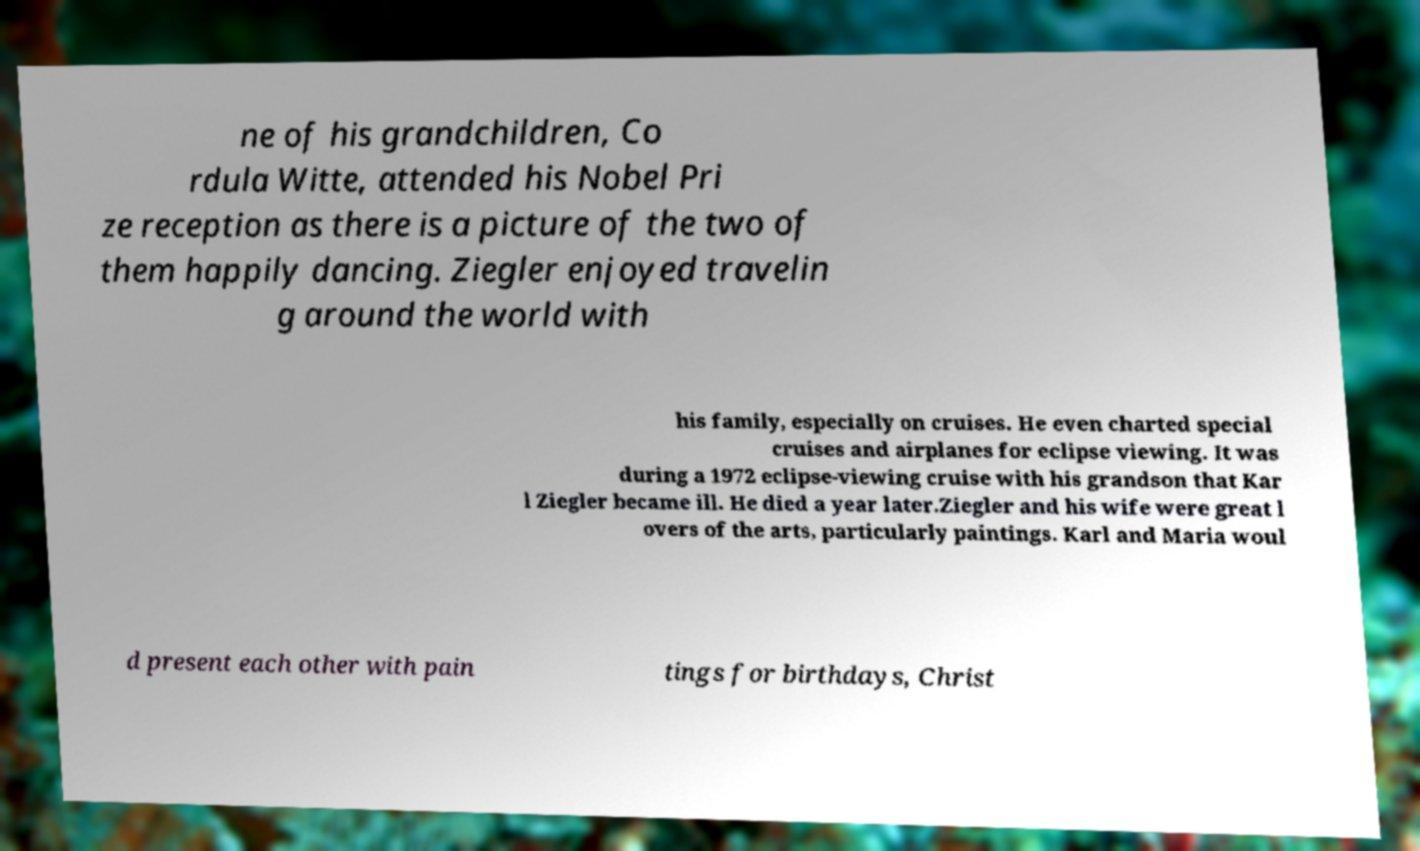What messages or text are displayed in this image? I need them in a readable, typed format. ne of his grandchildren, Co rdula Witte, attended his Nobel Pri ze reception as there is a picture of the two of them happily dancing. Ziegler enjoyed travelin g around the world with his family, especially on cruises. He even charted special cruises and airplanes for eclipse viewing. It was during a 1972 eclipse-viewing cruise with his grandson that Kar l Ziegler became ill. He died a year later.Ziegler and his wife were great l overs of the arts, particularly paintings. Karl and Maria woul d present each other with pain tings for birthdays, Christ 